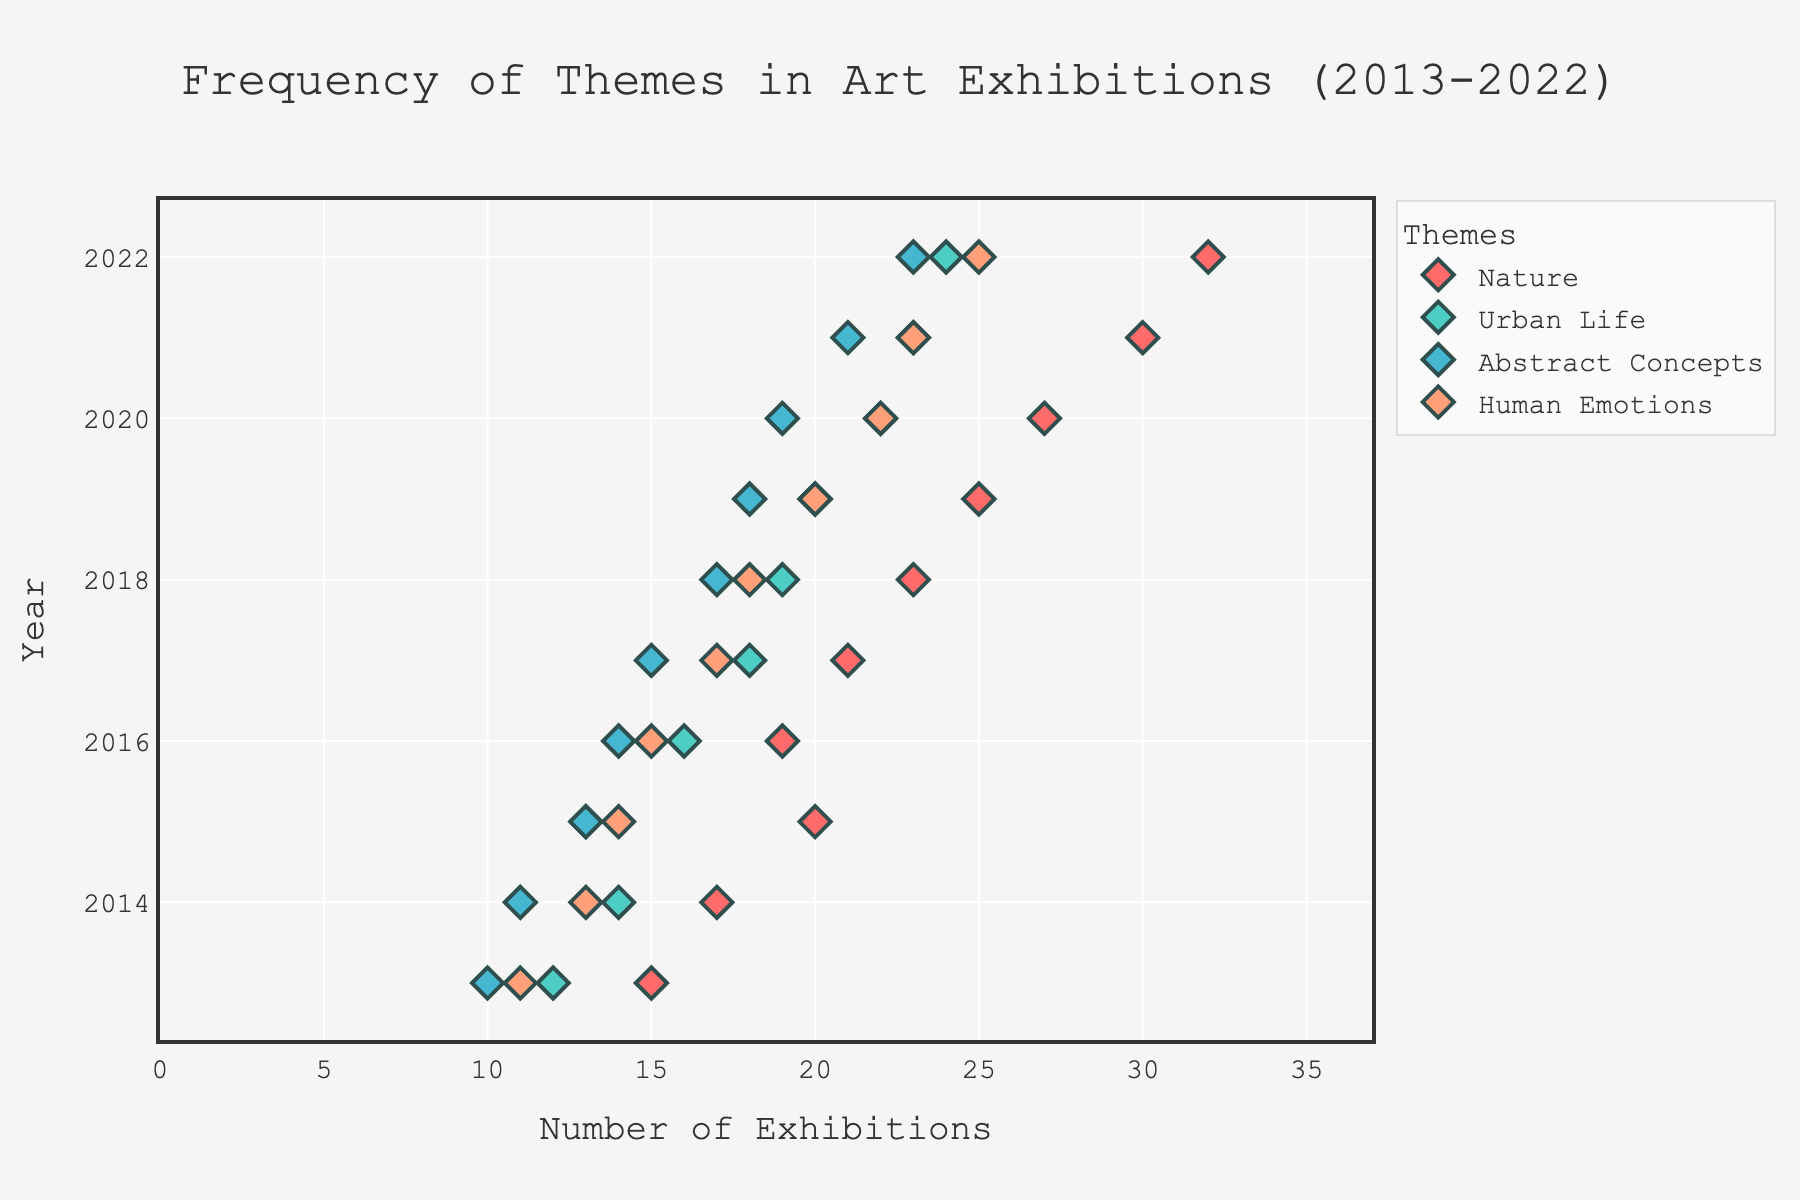What is the title of the plot? The title of the plot is written at the top and usually signifies what the plot represents. By reading it, you can understand the focus of the visual representation.
Answer: Frequency of Themes in Art Exhibitions (2013-2022) How many themes are tracked in the plot? By looking at the legend on the right side of the plot, you can count the number of different themes mentioned.
Answer: 4 Which theme has the highest frequency in 2022? By finding the data points for the year 2022 on the x-axis and checking which theme has the highest x value, you can determine which theme is most frequent.
Answer: Nature In which year did "Urban Life" surpass its halfway mark of 12 exhibitions? To find this, look at the data points for "Urban Life" and identify the first year where the number of exhibitions exceeds 12.
Answer: 2014 What is the average frequency of the "Abstract Concepts" exhibitions over the last decade? Sum the exhibition frequencies for "Abstract Concepts" from 2013 to 2022 and divide by the number of years (10). (10+11+13+14+15+17+18+19+21+23)/10 = 161/10
Answer: 16.1 Did the frequency of "Human Emotions" exhibitions show a general increase or decrease from 2013 to 2022? Observing the trend line from 2013 to 2022, if the data points are mostly rising, it indicates an increase; otherwise, a decrease. The points rise over time.
Answer: Increase By how many exhibitions did "Nature" exceed "Urban Life" in 2021? Find the exhibition frequencies for "Nature" and "Urban Life" in 2021 and subtract the latter from the former (30-23).
Answer: 7 Which theme had the least increase in frequency from 2013 to 2022? Calculate the difference in frequencies for each theme from 2013 to 2022 and find the smallest value. Only "Urban Life" had smallest increase (24-12=12).
Answer: Urban Life What is the trend of the "Urban Life" frequency over the plotted years? By examining the data points for "Urban Life" from 2013 to 2022, determine if it shows an upward, downward, or constant trend. The points generally rise over time.
Answer: Increasing Between "Abstract Concepts" and "Human Emotions", which theme had a higher frequency in 2018? Compare the respective data points for both themes in the year 2018. "Human Emotions" had 18 while "Abstract Concepts" had 17.
Answer: Human Emotions 